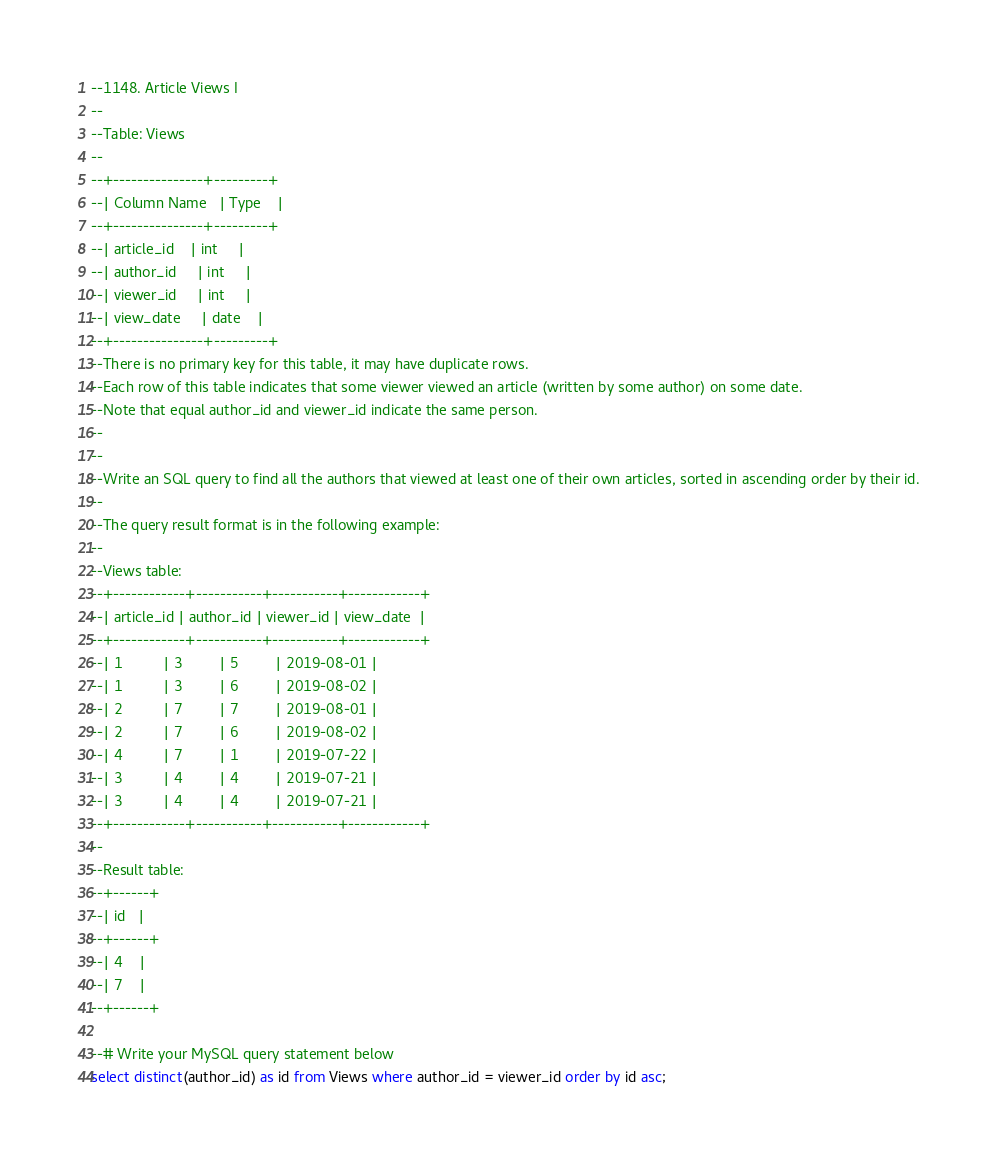Convert code to text. <code><loc_0><loc_0><loc_500><loc_500><_SQL_>--1148. Article Views I
--
--Table: Views
--
--+---------------+---------+
--| Column Name   | Type    |
--+---------------+---------+
--| article_id    | int     |
--| author_id     | int     |
--| viewer_id     | int     |
--| view_date     | date    |
--+---------------+---------+
--There is no primary key for this table, it may have duplicate rows.
--Each row of this table indicates that some viewer viewed an article (written by some author) on some date.
--Note that equal author_id and viewer_id indicate the same person.
--
--
--Write an SQL query to find all the authors that viewed at least one of their own articles, sorted in ascending order by their id.
--
--The query result format is in the following example:
--
--Views table:
--+------------+-----------+-----------+------------+
--| article_id | author_id | viewer_id | view_date  |
--+------------+-----------+-----------+------------+
--| 1          | 3         | 5         | 2019-08-01 |
--| 1          | 3         | 6         | 2019-08-02 |
--| 2          | 7         | 7         | 2019-08-01 |
--| 2          | 7         | 6         | 2019-08-02 |
--| 4          | 7         | 1         | 2019-07-22 |
--| 3          | 4         | 4         | 2019-07-21 |
--| 3          | 4         | 4         | 2019-07-21 |
--+------------+-----------+-----------+------------+
--
--Result table:
--+------+
--| id   |
--+------+
--| 4    |
--| 7    |
--+------+

--# Write your MySQL query statement below
select distinct(author_id) as id from Views where author_id = viewer_id order by id asc;</code> 